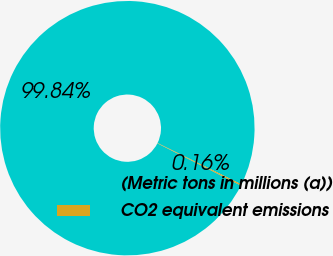Convert chart. <chart><loc_0><loc_0><loc_500><loc_500><pie_chart><fcel>(Metric tons in millions (a))<fcel>CO2 equivalent emissions<nl><fcel>99.84%<fcel>0.16%<nl></chart> 